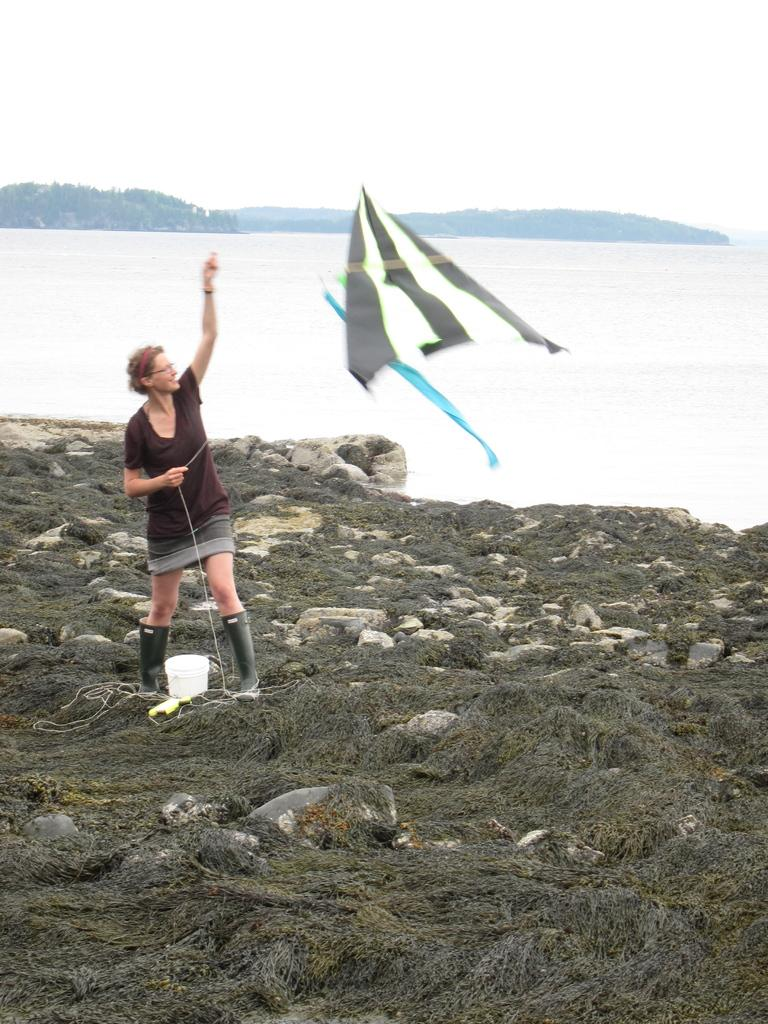Who is present in the image? There is a woman in the image. What is the woman doing in the image? The woman is standing in the image. What is the woman holding in the image? The woman is holding a kite in the image. What type of terrain is visible in the image? There are rocks and water visible in the image. What can be seen in the background of the image? There are hills in the background of the image. Where is the chair located in the image? There is no chair present in the image. Can you see a bike in the image? There is no bike present in the image. 